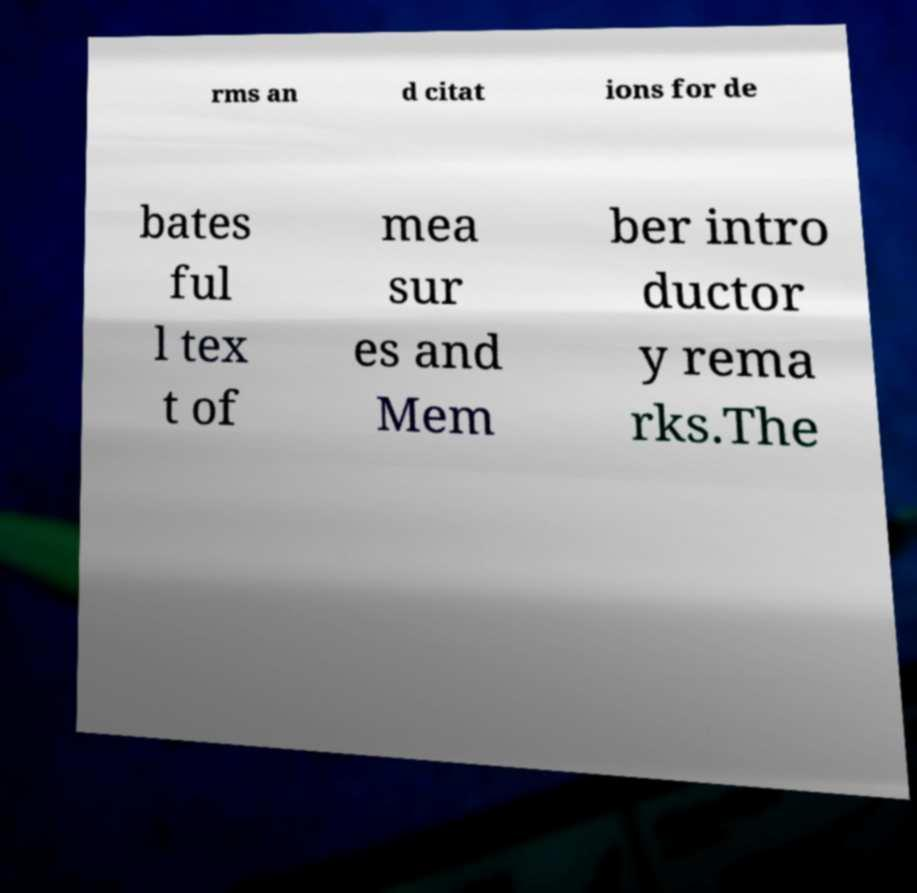Could you assist in decoding the text presented in this image and type it out clearly? rms an d citat ions for de bates ful l tex t of mea sur es and Mem ber intro ductor y rema rks.The 